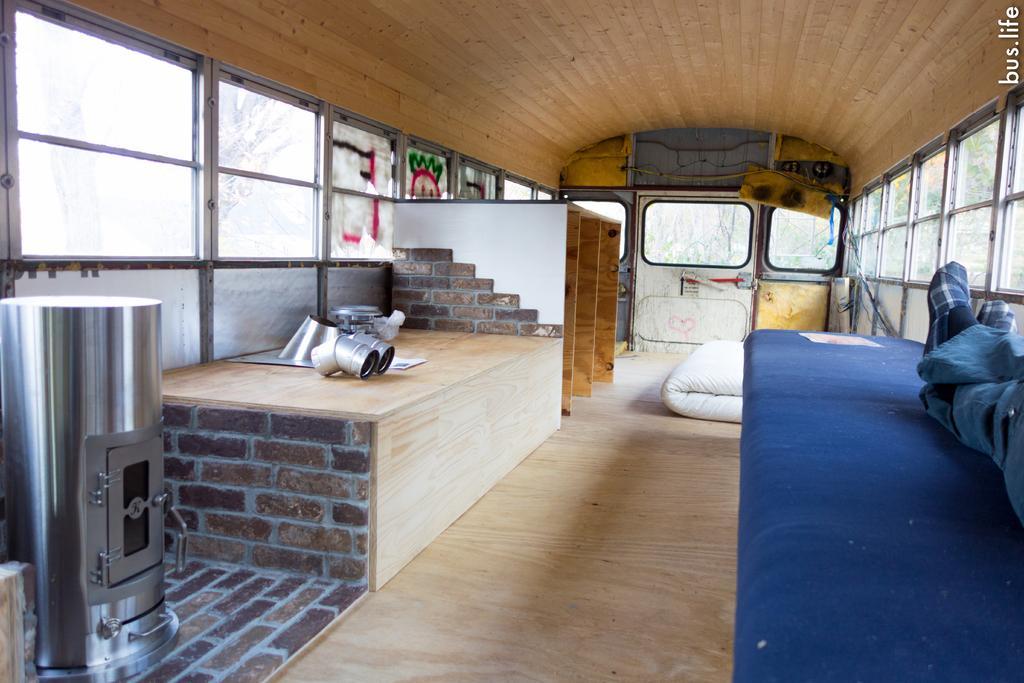How would you summarize this image in a sentence or two? In this picture we can see a few objects on the left side. There is a person sitting on the right side. We can see a cot mattress on the floor. Few trees are visible in the background. 